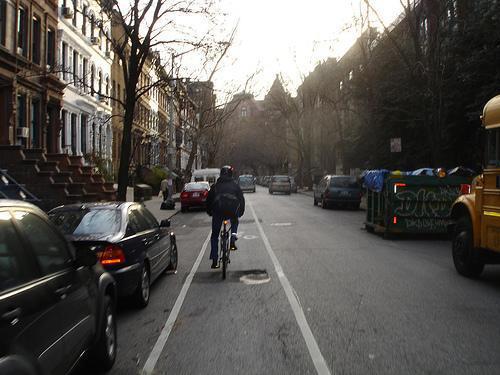How many bikes are there?
Give a very brief answer. 1. How many cares are to the left of the bike rider?
Give a very brief answer. 4. 